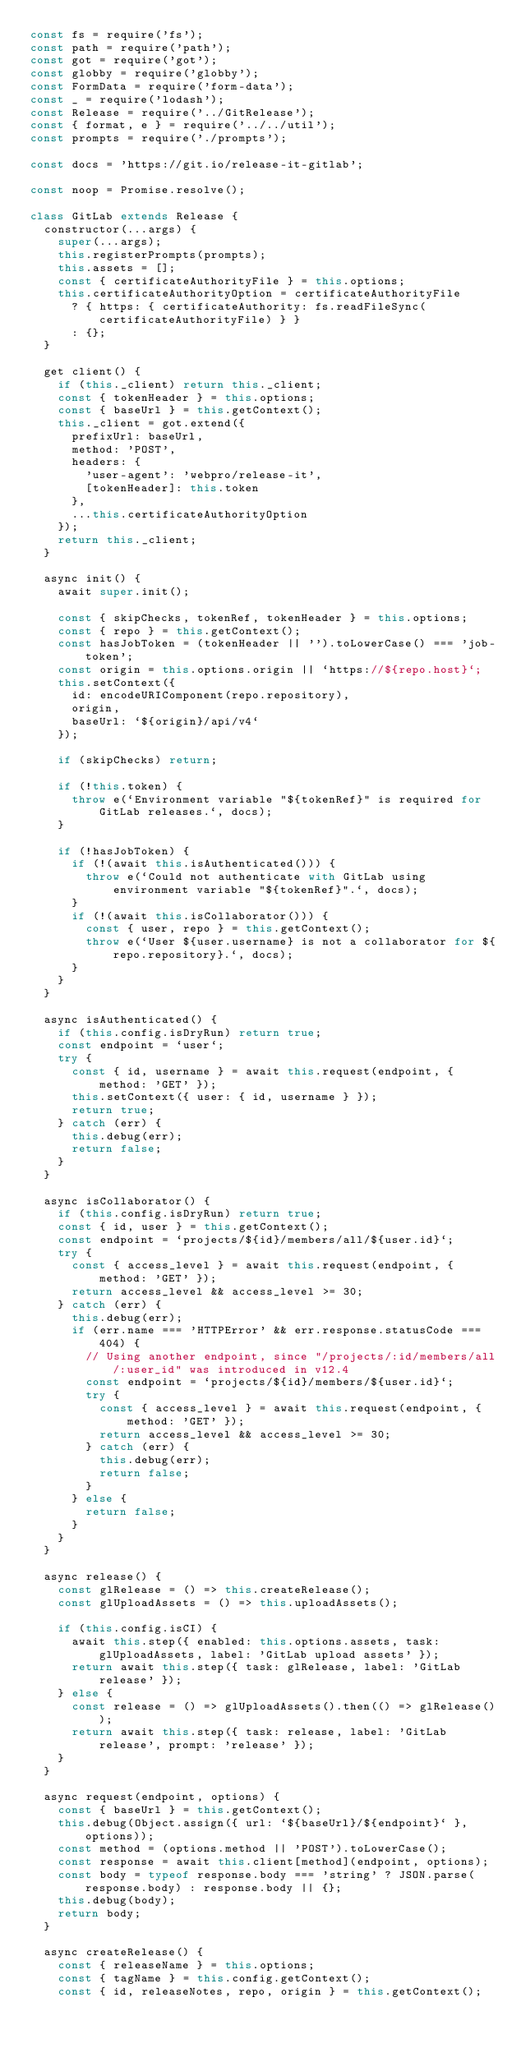<code> <loc_0><loc_0><loc_500><loc_500><_JavaScript_>const fs = require('fs');
const path = require('path');
const got = require('got');
const globby = require('globby');
const FormData = require('form-data');
const _ = require('lodash');
const Release = require('../GitRelease');
const { format, e } = require('../../util');
const prompts = require('./prompts');

const docs = 'https://git.io/release-it-gitlab';

const noop = Promise.resolve();

class GitLab extends Release {
  constructor(...args) {
    super(...args);
    this.registerPrompts(prompts);
    this.assets = [];
    const { certificateAuthorityFile } = this.options;
    this.certificateAuthorityOption = certificateAuthorityFile
      ? { https: { certificateAuthority: fs.readFileSync(certificateAuthorityFile) } }
      : {};
  }

  get client() {
    if (this._client) return this._client;
    const { tokenHeader } = this.options;
    const { baseUrl } = this.getContext();
    this._client = got.extend({
      prefixUrl: baseUrl,
      method: 'POST',
      headers: {
        'user-agent': 'webpro/release-it',
        [tokenHeader]: this.token
      },
      ...this.certificateAuthorityOption
    });
    return this._client;
  }

  async init() {
    await super.init();

    const { skipChecks, tokenRef, tokenHeader } = this.options;
    const { repo } = this.getContext();
    const hasJobToken = (tokenHeader || '').toLowerCase() === 'job-token';
    const origin = this.options.origin || `https://${repo.host}`;
    this.setContext({
      id: encodeURIComponent(repo.repository),
      origin,
      baseUrl: `${origin}/api/v4`
    });

    if (skipChecks) return;

    if (!this.token) {
      throw e(`Environment variable "${tokenRef}" is required for GitLab releases.`, docs);
    }

    if (!hasJobToken) {
      if (!(await this.isAuthenticated())) {
        throw e(`Could not authenticate with GitLab using environment variable "${tokenRef}".`, docs);
      }
      if (!(await this.isCollaborator())) {
        const { user, repo } = this.getContext();
        throw e(`User ${user.username} is not a collaborator for ${repo.repository}.`, docs);
      }
    }
  }

  async isAuthenticated() {
    if (this.config.isDryRun) return true;
    const endpoint = `user`;
    try {
      const { id, username } = await this.request(endpoint, { method: 'GET' });
      this.setContext({ user: { id, username } });
      return true;
    } catch (err) {
      this.debug(err);
      return false;
    }
  }

  async isCollaborator() {
    if (this.config.isDryRun) return true;
    const { id, user } = this.getContext();
    const endpoint = `projects/${id}/members/all/${user.id}`;
    try {
      const { access_level } = await this.request(endpoint, { method: 'GET' });
      return access_level && access_level >= 30;
    } catch (err) {
      this.debug(err);
      if (err.name === 'HTTPError' && err.response.statusCode === 404) {
        // Using another endpoint, since "/projects/:id/members/all/:user_id" was introduced in v12.4
        const endpoint = `projects/${id}/members/${user.id}`;
        try {
          const { access_level } = await this.request(endpoint, { method: 'GET' });
          return access_level && access_level >= 30;
        } catch (err) {
          this.debug(err);
          return false;
        }
      } else {
        return false;
      }
    }
  }

  async release() {
    const glRelease = () => this.createRelease();
    const glUploadAssets = () => this.uploadAssets();

    if (this.config.isCI) {
      await this.step({ enabled: this.options.assets, task: glUploadAssets, label: 'GitLab upload assets' });
      return await this.step({ task: glRelease, label: 'GitLab release' });
    } else {
      const release = () => glUploadAssets().then(() => glRelease());
      return await this.step({ task: release, label: 'GitLab release', prompt: 'release' });
    }
  }

  async request(endpoint, options) {
    const { baseUrl } = this.getContext();
    this.debug(Object.assign({ url: `${baseUrl}/${endpoint}` }, options));
    const method = (options.method || 'POST').toLowerCase();
    const response = await this.client[method](endpoint, options);
    const body = typeof response.body === 'string' ? JSON.parse(response.body) : response.body || {};
    this.debug(body);
    return body;
  }

  async createRelease() {
    const { releaseName } = this.options;
    const { tagName } = this.config.getContext();
    const { id, releaseNotes, repo, origin } = this.getContext();</code> 